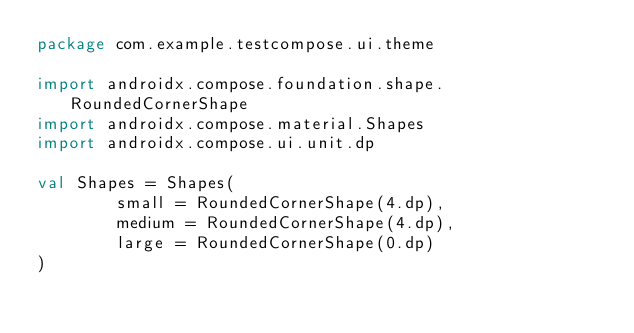Convert code to text. <code><loc_0><loc_0><loc_500><loc_500><_Kotlin_>package com.example.testcompose.ui.theme

import androidx.compose.foundation.shape.RoundedCornerShape
import androidx.compose.material.Shapes
import androidx.compose.ui.unit.dp

val Shapes = Shapes(
        small = RoundedCornerShape(4.dp),
        medium = RoundedCornerShape(4.dp),
        large = RoundedCornerShape(0.dp)
)</code> 